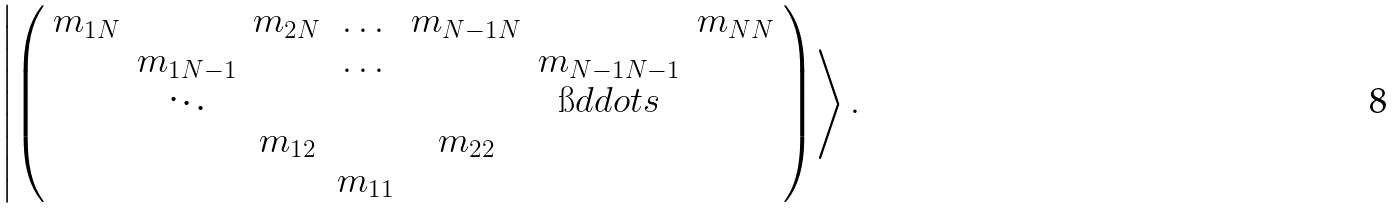<formula> <loc_0><loc_0><loc_500><loc_500>\left | \left ( \begin{array} { c c c c c c c } m _ { 1 N } & & m _ { 2 N } & \dots & m _ { N - 1 N } & & m _ { N N } \\ & m _ { 1 N - 1 } & & \dots & & m _ { N - 1 N - 1 } & \\ & \ddots & & & & \i d d o t s & \\ & & m _ { 1 2 } & & m _ { 2 2 } & & \\ & & & m _ { 1 1 } & & & \\ \end{array} \right ) \right > .</formula> 